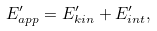<formula> <loc_0><loc_0><loc_500><loc_500>E _ { a p p } ^ { \prime } = E _ { k i n } ^ { \prime } + E _ { i n t } ^ { \prime } ,</formula> 